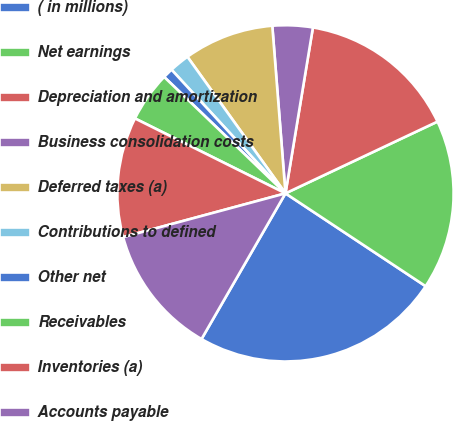<chart> <loc_0><loc_0><loc_500><loc_500><pie_chart><fcel>( in millions)<fcel>Net earnings<fcel>Depreciation and amortization<fcel>Business consolidation costs<fcel>Deferred taxes (a)<fcel>Contributions to defined<fcel>Other net<fcel>Receivables<fcel>Inventories (a)<fcel>Accounts payable<nl><fcel>24.01%<fcel>16.33%<fcel>15.37%<fcel>3.86%<fcel>8.66%<fcel>1.94%<fcel>0.98%<fcel>4.82%<fcel>11.54%<fcel>12.49%<nl></chart> 